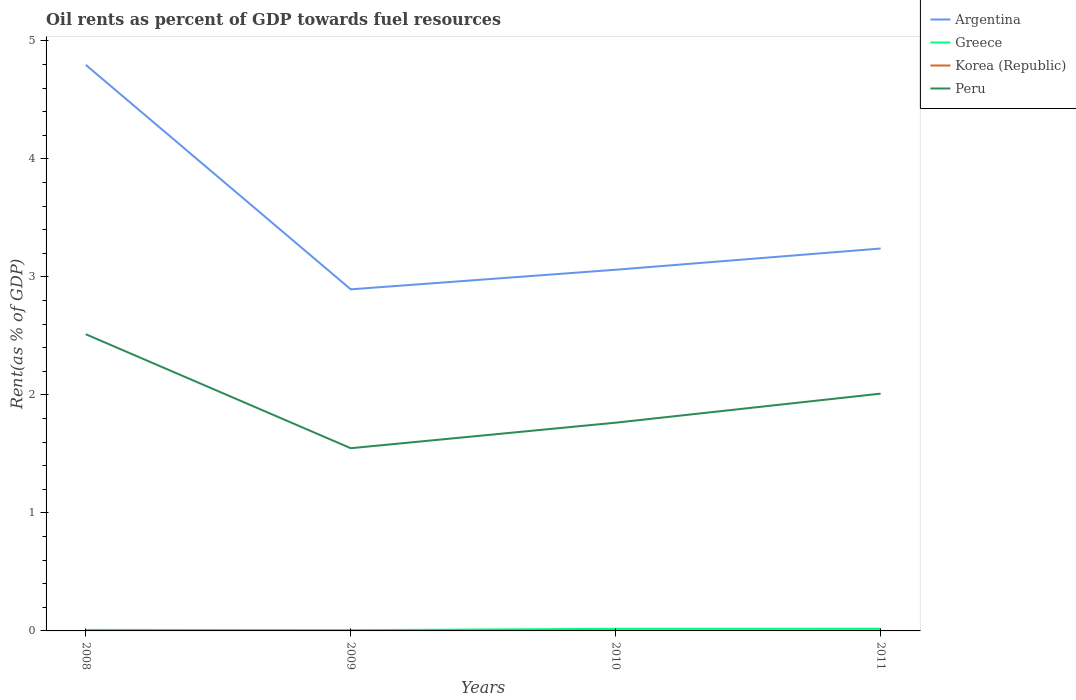How many different coloured lines are there?
Your answer should be compact. 4. Does the line corresponding to Argentina intersect with the line corresponding to Korea (Republic)?
Give a very brief answer. No. Across all years, what is the maximum oil rent in Greece?
Provide a succinct answer. 0.01. In which year was the oil rent in Peru maximum?
Ensure brevity in your answer.  2009. What is the total oil rent in Peru in the graph?
Make the answer very short. 0.97. What is the difference between the highest and the second highest oil rent in Korea (Republic)?
Provide a short and direct response. 0. What is the difference between the highest and the lowest oil rent in Argentina?
Keep it short and to the point. 1. Is the oil rent in Peru strictly greater than the oil rent in Argentina over the years?
Keep it short and to the point. Yes. How many lines are there?
Ensure brevity in your answer.  4. What is the difference between two consecutive major ticks on the Y-axis?
Your answer should be very brief. 1. Does the graph contain any zero values?
Keep it short and to the point. No. How many legend labels are there?
Offer a terse response. 4. What is the title of the graph?
Provide a succinct answer. Oil rents as percent of GDP towards fuel resources. Does "Slovak Republic" appear as one of the legend labels in the graph?
Make the answer very short. No. What is the label or title of the Y-axis?
Offer a terse response. Rent(as % of GDP). What is the Rent(as % of GDP) of Argentina in 2008?
Ensure brevity in your answer.  4.8. What is the Rent(as % of GDP) of Greece in 2008?
Ensure brevity in your answer.  0.01. What is the Rent(as % of GDP) in Korea (Republic) in 2008?
Your answer should be very brief. 0. What is the Rent(as % of GDP) in Peru in 2008?
Offer a terse response. 2.51. What is the Rent(as % of GDP) in Argentina in 2009?
Provide a short and direct response. 2.89. What is the Rent(as % of GDP) of Greece in 2009?
Offer a very short reply. 0.01. What is the Rent(as % of GDP) in Korea (Republic) in 2009?
Ensure brevity in your answer.  0. What is the Rent(as % of GDP) in Peru in 2009?
Offer a very short reply. 1.55. What is the Rent(as % of GDP) of Argentina in 2010?
Offer a very short reply. 3.06. What is the Rent(as % of GDP) in Greece in 2010?
Your answer should be very brief. 0.02. What is the Rent(as % of GDP) of Korea (Republic) in 2010?
Your answer should be compact. 0. What is the Rent(as % of GDP) in Peru in 2010?
Provide a short and direct response. 1.76. What is the Rent(as % of GDP) of Argentina in 2011?
Your answer should be very brief. 3.24. What is the Rent(as % of GDP) of Greece in 2011?
Your answer should be compact. 0.02. What is the Rent(as % of GDP) of Korea (Republic) in 2011?
Give a very brief answer. 0. What is the Rent(as % of GDP) in Peru in 2011?
Make the answer very short. 2.01. Across all years, what is the maximum Rent(as % of GDP) of Argentina?
Provide a short and direct response. 4.8. Across all years, what is the maximum Rent(as % of GDP) of Greece?
Your response must be concise. 0.02. Across all years, what is the maximum Rent(as % of GDP) of Korea (Republic)?
Give a very brief answer. 0. Across all years, what is the maximum Rent(as % of GDP) of Peru?
Ensure brevity in your answer.  2.51. Across all years, what is the minimum Rent(as % of GDP) in Argentina?
Ensure brevity in your answer.  2.89. Across all years, what is the minimum Rent(as % of GDP) of Greece?
Provide a short and direct response. 0.01. Across all years, what is the minimum Rent(as % of GDP) of Korea (Republic)?
Offer a very short reply. 0. Across all years, what is the minimum Rent(as % of GDP) in Peru?
Keep it short and to the point. 1.55. What is the total Rent(as % of GDP) of Argentina in the graph?
Give a very brief answer. 13.99. What is the total Rent(as % of GDP) in Greece in the graph?
Your response must be concise. 0.05. What is the total Rent(as % of GDP) in Korea (Republic) in the graph?
Your answer should be compact. 0.01. What is the total Rent(as % of GDP) of Peru in the graph?
Give a very brief answer. 7.84. What is the difference between the Rent(as % of GDP) of Argentina in 2008 and that in 2009?
Provide a short and direct response. 1.9. What is the difference between the Rent(as % of GDP) in Greece in 2008 and that in 2009?
Offer a very short reply. 0. What is the difference between the Rent(as % of GDP) in Korea (Republic) in 2008 and that in 2009?
Offer a very short reply. -0. What is the difference between the Rent(as % of GDP) in Peru in 2008 and that in 2009?
Provide a succinct answer. 0.97. What is the difference between the Rent(as % of GDP) of Argentina in 2008 and that in 2010?
Offer a very short reply. 1.74. What is the difference between the Rent(as % of GDP) in Greece in 2008 and that in 2010?
Your response must be concise. -0.01. What is the difference between the Rent(as % of GDP) of Korea (Republic) in 2008 and that in 2010?
Your answer should be very brief. -0. What is the difference between the Rent(as % of GDP) in Peru in 2008 and that in 2010?
Your answer should be compact. 0.75. What is the difference between the Rent(as % of GDP) of Argentina in 2008 and that in 2011?
Offer a very short reply. 1.56. What is the difference between the Rent(as % of GDP) in Greece in 2008 and that in 2011?
Provide a succinct answer. -0.01. What is the difference between the Rent(as % of GDP) of Korea (Republic) in 2008 and that in 2011?
Ensure brevity in your answer.  -0. What is the difference between the Rent(as % of GDP) in Peru in 2008 and that in 2011?
Offer a very short reply. 0.5. What is the difference between the Rent(as % of GDP) of Argentina in 2009 and that in 2010?
Offer a terse response. -0.17. What is the difference between the Rent(as % of GDP) in Greece in 2009 and that in 2010?
Make the answer very short. -0.01. What is the difference between the Rent(as % of GDP) of Korea (Republic) in 2009 and that in 2010?
Make the answer very short. -0. What is the difference between the Rent(as % of GDP) of Peru in 2009 and that in 2010?
Make the answer very short. -0.22. What is the difference between the Rent(as % of GDP) in Argentina in 2009 and that in 2011?
Provide a short and direct response. -0.35. What is the difference between the Rent(as % of GDP) in Greece in 2009 and that in 2011?
Your response must be concise. -0.01. What is the difference between the Rent(as % of GDP) in Korea (Republic) in 2009 and that in 2011?
Ensure brevity in your answer.  -0. What is the difference between the Rent(as % of GDP) in Peru in 2009 and that in 2011?
Make the answer very short. -0.46. What is the difference between the Rent(as % of GDP) in Argentina in 2010 and that in 2011?
Keep it short and to the point. -0.18. What is the difference between the Rent(as % of GDP) of Greece in 2010 and that in 2011?
Offer a very short reply. -0. What is the difference between the Rent(as % of GDP) of Korea (Republic) in 2010 and that in 2011?
Give a very brief answer. 0. What is the difference between the Rent(as % of GDP) of Peru in 2010 and that in 2011?
Make the answer very short. -0.25. What is the difference between the Rent(as % of GDP) of Argentina in 2008 and the Rent(as % of GDP) of Greece in 2009?
Provide a short and direct response. 4.79. What is the difference between the Rent(as % of GDP) of Argentina in 2008 and the Rent(as % of GDP) of Korea (Republic) in 2009?
Ensure brevity in your answer.  4.79. What is the difference between the Rent(as % of GDP) in Argentina in 2008 and the Rent(as % of GDP) in Peru in 2009?
Provide a short and direct response. 3.25. What is the difference between the Rent(as % of GDP) in Greece in 2008 and the Rent(as % of GDP) in Korea (Republic) in 2009?
Your answer should be compact. 0.01. What is the difference between the Rent(as % of GDP) of Greece in 2008 and the Rent(as % of GDP) of Peru in 2009?
Your response must be concise. -1.54. What is the difference between the Rent(as % of GDP) of Korea (Republic) in 2008 and the Rent(as % of GDP) of Peru in 2009?
Give a very brief answer. -1.55. What is the difference between the Rent(as % of GDP) in Argentina in 2008 and the Rent(as % of GDP) in Greece in 2010?
Provide a succinct answer. 4.78. What is the difference between the Rent(as % of GDP) of Argentina in 2008 and the Rent(as % of GDP) of Korea (Republic) in 2010?
Keep it short and to the point. 4.79. What is the difference between the Rent(as % of GDP) in Argentina in 2008 and the Rent(as % of GDP) in Peru in 2010?
Offer a terse response. 3.03. What is the difference between the Rent(as % of GDP) of Greece in 2008 and the Rent(as % of GDP) of Korea (Republic) in 2010?
Offer a terse response. 0.01. What is the difference between the Rent(as % of GDP) of Greece in 2008 and the Rent(as % of GDP) of Peru in 2010?
Make the answer very short. -1.76. What is the difference between the Rent(as % of GDP) in Korea (Republic) in 2008 and the Rent(as % of GDP) in Peru in 2010?
Your answer should be very brief. -1.76. What is the difference between the Rent(as % of GDP) of Argentina in 2008 and the Rent(as % of GDP) of Greece in 2011?
Ensure brevity in your answer.  4.78. What is the difference between the Rent(as % of GDP) in Argentina in 2008 and the Rent(as % of GDP) in Korea (Republic) in 2011?
Give a very brief answer. 4.79. What is the difference between the Rent(as % of GDP) in Argentina in 2008 and the Rent(as % of GDP) in Peru in 2011?
Offer a terse response. 2.79. What is the difference between the Rent(as % of GDP) of Greece in 2008 and the Rent(as % of GDP) of Korea (Republic) in 2011?
Your response must be concise. 0.01. What is the difference between the Rent(as % of GDP) in Greece in 2008 and the Rent(as % of GDP) in Peru in 2011?
Give a very brief answer. -2. What is the difference between the Rent(as % of GDP) in Korea (Republic) in 2008 and the Rent(as % of GDP) in Peru in 2011?
Provide a short and direct response. -2.01. What is the difference between the Rent(as % of GDP) of Argentina in 2009 and the Rent(as % of GDP) of Greece in 2010?
Provide a short and direct response. 2.88. What is the difference between the Rent(as % of GDP) in Argentina in 2009 and the Rent(as % of GDP) in Korea (Republic) in 2010?
Offer a very short reply. 2.89. What is the difference between the Rent(as % of GDP) in Argentina in 2009 and the Rent(as % of GDP) in Peru in 2010?
Ensure brevity in your answer.  1.13. What is the difference between the Rent(as % of GDP) of Greece in 2009 and the Rent(as % of GDP) of Korea (Republic) in 2010?
Keep it short and to the point. 0. What is the difference between the Rent(as % of GDP) of Greece in 2009 and the Rent(as % of GDP) of Peru in 2010?
Offer a terse response. -1.76. What is the difference between the Rent(as % of GDP) in Korea (Republic) in 2009 and the Rent(as % of GDP) in Peru in 2010?
Offer a very short reply. -1.76. What is the difference between the Rent(as % of GDP) of Argentina in 2009 and the Rent(as % of GDP) of Greece in 2011?
Your answer should be very brief. 2.88. What is the difference between the Rent(as % of GDP) of Argentina in 2009 and the Rent(as % of GDP) of Korea (Republic) in 2011?
Give a very brief answer. 2.89. What is the difference between the Rent(as % of GDP) in Argentina in 2009 and the Rent(as % of GDP) in Peru in 2011?
Make the answer very short. 0.88. What is the difference between the Rent(as % of GDP) in Greece in 2009 and the Rent(as % of GDP) in Korea (Republic) in 2011?
Provide a short and direct response. 0. What is the difference between the Rent(as % of GDP) of Greece in 2009 and the Rent(as % of GDP) of Peru in 2011?
Make the answer very short. -2. What is the difference between the Rent(as % of GDP) of Korea (Republic) in 2009 and the Rent(as % of GDP) of Peru in 2011?
Offer a very short reply. -2.01. What is the difference between the Rent(as % of GDP) of Argentina in 2010 and the Rent(as % of GDP) of Greece in 2011?
Provide a succinct answer. 3.04. What is the difference between the Rent(as % of GDP) of Argentina in 2010 and the Rent(as % of GDP) of Korea (Republic) in 2011?
Provide a short and direct response. 3.06. What is the difference between the Rent(as % of GDP) of Argentina in 2010 and the Rent(as % of GDP) of Peru in 2011?
Give a very brief answer. 1.05. What is the difference between the Rent(as % of GDP) of Greece in 2010 and the Rent(as % of GDP) of Korea (Republic) in 2011?
Provide a succinct answer. 0.02. What is the difference between the Rent(as % of GDP) of Greece in 2010 and the Rent(as % of GDP) of Peru in 2011?
Your answer should be very brief. -1.99. What is the difference between the Rent(as % of GDP) of Korea (Republic) in 2010 and the Rent(as % of GDP) of Peru in 2011?
Offer a terse response. -2.01. What is the average Rent(as % of GDP) in Argentina per year?
Offer a very short reply. 3.5. What is the average Rent(as % of GDP) of Greece per year?
Keep it short and to the point. 0.01. What is the average Rent(as % of GDP) of Korea (Republic) per year?
Make the answer very short. 0. What is the average Rent(as % of GDP) of Peru per year?
Keep it short and to the point. 1.96. In the year 2008, what is the difference between the Rent(as % of GDP) in Argentina and Rent(as % of GDP) in Greece?
Ensure brevity in your answer.  4.79. In the year 2008, what is the difference between the Rent(as % of GDP) in Argentina and Rent(as % of GDP) in Korea (Republic)?
Offer a terse response. 4.8. In the year 2008, what is the difference between the Rent(as % of GDP) of Argentina and Rent(as % of GDP) of Peru?
Your answer should be very brief. 2.28. In the year 2008, what is the difference between the Rent(as % of GDP) of Greece and Rent(as % of GDP) of Korea (Republic)?
Offer a very short reply. 0.01. In the year 2008, what is the difference between the Rent(as % of GDP) in Greece and Rent(as % of GDP) in Peru?
Ensure brevity in your answer.  -2.51. In the year 2008, what is the difference between the Rent(as % of GDP) of Korea (Republic) and Rent(as % of GDP) of Peru?
Your response must be concise. -2.51. In the year 2009, what is the difference between the Rent(as % of GDP) of Argentina and Rent(as % of GDP) of Greece?
Keep it short and to the point. 2.89. In the year 2009, what is the difference between the Rent(as % of GDP) of Argentina and Rent(as % of GDP) of Korea (Republic)?
Make the answer very short. 2.89. In the year 2009, what is the difference between the Rent(as % of GDP) of Argentina and Rent(as % of GDP) of Peru?
Ensure brevity in your answer.  1.35. In the year 2009, what is the difference between the Rent(as % of GDP) of Greece and Rent(as % of GDP) of Korea (Republic)?
Provide a short and direct response. 0. In the year 2009, what is the difference between the Rent(as % of GDP) in Greece and Rent(as % of GDP) in Peru?
Your answer should be compact. -1.54. In the year 2009, what is the difference between the Rent(as % of GDP) of Korea (Republic) and Rent(as % of GDP) of Peru?
Ensure brevity in your answer.  -1.55. In the year 2010, what is the difference between the Rent(as % of GDP) of Argentina and Rent(as % of GDP) of Greece?
Ensure brevity in your answer.  3.04. In the year 2010, what is the difference between the Rent(as % of GDP) in Argentina and Rent(as % of GDP) in Korea (Republic)?
Your answer should be compact. 3.06. In the year 2010, what is the difference between the Rent(as % of GDP) of Argentina and Rent(as % of GDP) of Peru?
Ensure brevity in your answer.  1.3. In the year 2010, what is the difference between the Rent(as % of GDP) of Greece and Rent(as % of GDP) of Korea (Republic)?
Offer a terse response. 0.02. In the year 2010, what is the difference between the Rent(as % of GDP) of Greece and Rent(as % of GDP) of Peru?
Ensure brevity in your answer.  -1.75. In the year 2010, what is the difference between the Rent(as % of GDP) in Korea (Republic) and Rent(as % of GDP) in Peru?
Your answer should be very brief. -1.76. In the year 2011, what is the difference between the Rent(as % of GDP) of Argentina and Rent(as % of GDP) of Greece?
Make the answer very short. 3.22. In the year 2011, what is the difference between the Rent(as % of GDP) in Argentina and Rent(as % of GDP) in Korea (Republic)?
Provide a short and direct response. 3.24. In the year 2011, what is the difference between the Rent(as % of GDP) of Argentina and Rent(as % of GDP) of Peru?
Your response must be concise. 1.23. In the year 2011, what is the difference between the Rent(as % of GDP) in Greece and Rent(as % of GDP) in Korea (Republic)?
Offer a terse response. 0.02. In the year 2011, what is the difference between the Rent(as % of GDP) of Greece and Rent(as % of GDP) of Peru?
Give a very brief answer. -1.99. In the year 2011, what is the difference between the Rent(as % of GDP) of Korea (Republic) and Rent(as % of GDP) of Peru?
Provide a short and direct response. -2.01. What is the ratio of the Rent(as % of GDP) of Argentina in 2008 to that in 2009?
Offer a very short reply. 1.66. What is the ratio of the Rent(as % of GDP) in Greece in 2008 to that in 2009?
Your answer should be very brief. 1.42. What is the ratio of the Rent(as % of GDP) of Korea (Republic) in 2008 to that in 2009?
Offer a very short reply. 0.77. What is the ratio of the Rent(as % of GDP) in Peru in 2008 to that in 2009?
Keep it short and to the point. 1.62. What is the ratio of the Rent(as % of GDP) of Argentina in 2008 to that in 2010?
Provide a short and direct response. 1.57. What is the ratio of the Rent(as % of GDP) in Greece in 2008 to that in 2010?
Offer a very short reply. 0.49. What is the ratio of the Rent(as % of GDP) in Korea (Republic) in 2008 to that in 2010?
Offer a very short reply. 0.56. What is the ratio of the Rent(as % of GDP) in Peru in 2008 to that in 2010?
Your answer should be very brief. 1.42. What is the ratio of the Rent(as % of GDP) in Argentina in 2008 to that in 2011?
Provide a succinct answer. 1.48. What is the ratio of the Rent(as % of GDP) of Greece in 2008 to that in 2011?
Provide a succinct answer. 0.46. What is the ratio of the Rent(as % of GDP) of Korea (Republic) in 2008 to that in 2011?
Keep it short and to the point. 0.63. What is the ratio of the Rent(as % of GDP) of Peru in 2008 to that in 2011?
Provide a succinct answer. 1.25. What is the ratio of the Rent(as % of GDP) in Argentina in 2009 to that in 2010?
Provide a succinct answer. 0.95. What is the ratio of the Rent(as % of GDP) in Greece in 2009 to that in 2010?
Your answer should be compact. 0.34. What is the ratio of the Rent(as % of GDP) in Korea (Republic) in 2009 to that in 2010?
Give a very brief answer. 0.73. What is the ratio of the Rent(as % of GDP) of Peru in 2009 to that in 2010?
Offer a very short reply. 0.88. What is the ratio of the Rent(as % of GDP) in Argentina in 2009 to that in 2011?
Offer a terse response. 0.89. What is the ratio of the Rent(as % of GDP) in Greece in 2009 to that in 2011?
Your answer should be very brief. 0.33. What is the ratio of the Rent(as % of GDP) in Korea (Republic) in 2009 to that in 2011?
Provide a short and direct response. 0.82. What is the ratio of the Rent(as % of GDP) of Peru in 2009 to that in 2011?
Ensure brevity in your answer.  0.77. What is the ratio of the Rent(as % of GDP) of Argentina in 2010 to that in 2011?
Offer a very short reply. 0.94. What is the ratio of the Rent(as % of GDP) of Greece in 2010 to that in 2011?
Your response must be concise. 0.96. What is the ratio of the Rent(as % of GDP) in Korea (Republic) in 2010 to that in 2011?
Make the answer very short. 1.12. What is the ratio of the Rent(as % of GDP) of Peru in 2010 to that in 2011?
Offer a very short reply. 0.88. What is the difference between the highest and the second highest Rent(as % of GDP) in Argentina?
Your answer should be very brief. 1.56. What is the difference between the highest and the second highest Rent(as % of GDP) of Greece?
Offer a terse response. 0. What is the difference between the highest and the second highest Rent(as % of GDP) of Korea (Republic)?
Keep it short and to the point. 0. What is the difference between the highest and the second highest Rent(as % of GDP) in Peru?
Provide a short and direct response. 0.5. What is the difference between the highest and the lowest Rent(as % of GDP) in Argentina?
Your response must be concise. 1.9. What is the difference between the highest and the lowest Rent(as % of GDP) in Greece?
Make the answer very short. 0.01. What is the difference between the highest and the lowest Rent(as % of GDP) in Peru?
Offer a terse response. 0.97. 